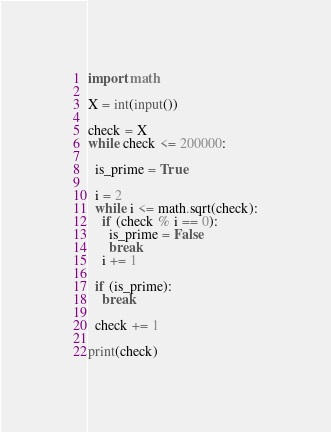Convert code to text. <code><loc_0><loc_0><loc_500><loc_500><_Python_>import math

X = int(input())

check = X
while check <= 200000:

  is_prime = True

  i = 2
  while i <= math.sqrt(check):
    if (check % i == 0):
      is_prime = False
      break
    i += 1

  if (is_prime):
    break

  check += 1

print(check)
</code> 